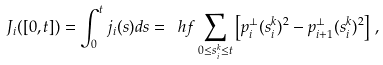<formula> <loc_0><loc_0><loc_500><loc_500>J _ { i } ( [ 0 , t ] ) = \int _ { 0 } ^ { t } j _ { i } ( s ) d s = \ h f \sum _ { 0 \leq s ^ { k } _ { i } \leq t } \left [ p _ { i } ^ { \bot } ( s ^ { k } _ { i } ) ^ { 2 } - p ^ { \bot } _ { i + 1 } ( s ^ { k } _ { i } ) ^ { 2 } \right ] \, ,</formula> 